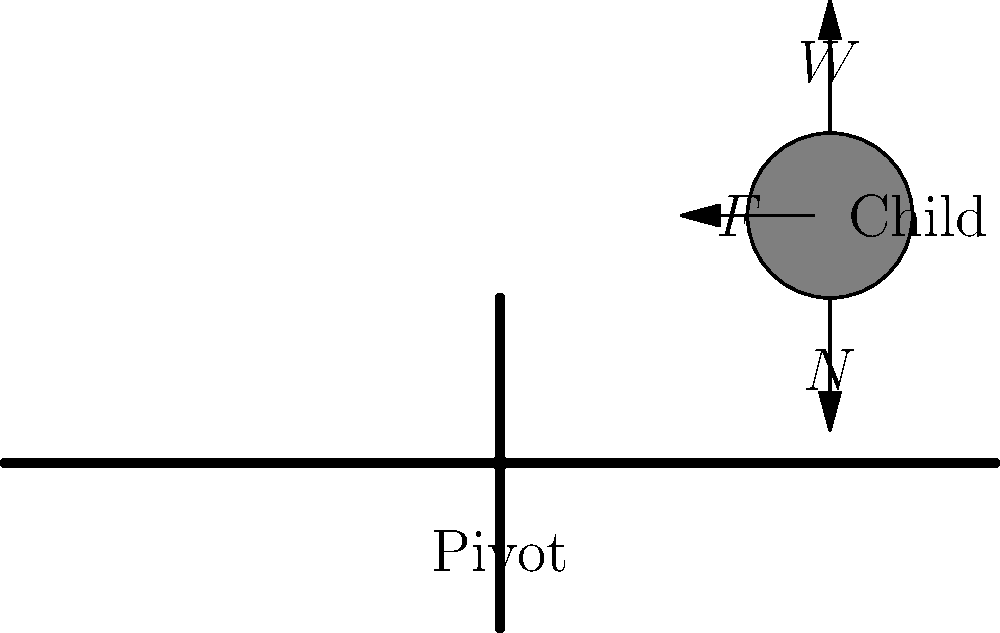Your child is playing on a seesaw at the playground. If the child weighs 30 kg and is sitting 2 meters from the pivot point, what is the magnitude of the force (F) applied by the seesaw on the child to keep them balanced? (Assume the seesaw is perfectly horizontal and ignore its weight) Let's approach this step-by-step:

1) First, we need to identify the forces acting on the child:
   - Weight (W): The downward force due to gravity
   - Normal force (N): The upward force from the seesaw
   - Horizontal force (F): The force applied by the seesaw to keep the child from sliding

2) The child's weight:
   $W = mg = 30 \text{ kg} \times 9.8 \text{ m/s}^2 = 294 \text{ N}$

3) Since the seesaw is horizontal and stationary, the normal force (N) must be equal and opposite to the weight:
   $N = W = 294 \text{ N}$

4) To find F, we need to consider the moment (rotational force) about the pivot point:
   - The moment caused by the child's weight: $294 \text{ N} \times 2 \text{ m} = 588 \text{ N·m}$
   - This moment must be balanced by the moment caused by F

5) The moment equation:
   $F \times h = 294 \text{ N} \times 2 \text{ m}$
   Where h is the height of the seesaw at the child's position

6) To find h, we can use the Pythagorean theorem:
   $h^2 + 2^2 = 2.5^2$ (assuming the seesaw is 2.5 m long)
   $h^2 = 2.5^2 - 2^2 = 6.25 - 4 = 2.25$
   $h = \sqrt{2.25} = 1.5 \text{ m}$

7) Now we can solve for F:
   $F \times 1.5 \text{ m} = 588 \text{ N·m}$
   $F = 588 \text{ N·m} \div 1.5 \text{ m} = 392 \text{ N}$

Therefore, the magnitude of the force F is 392 N.
Answer: 392 N 